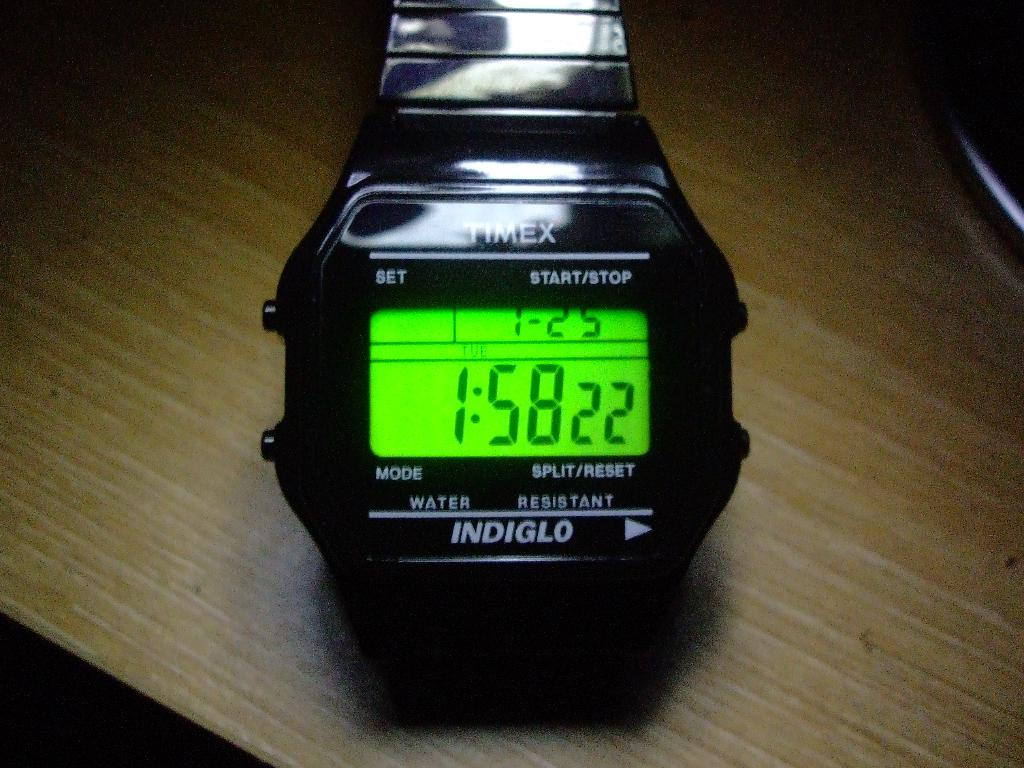Provide a one-sentence caption for the provided image. The black Timex watch is illuminated by Indiglo. 